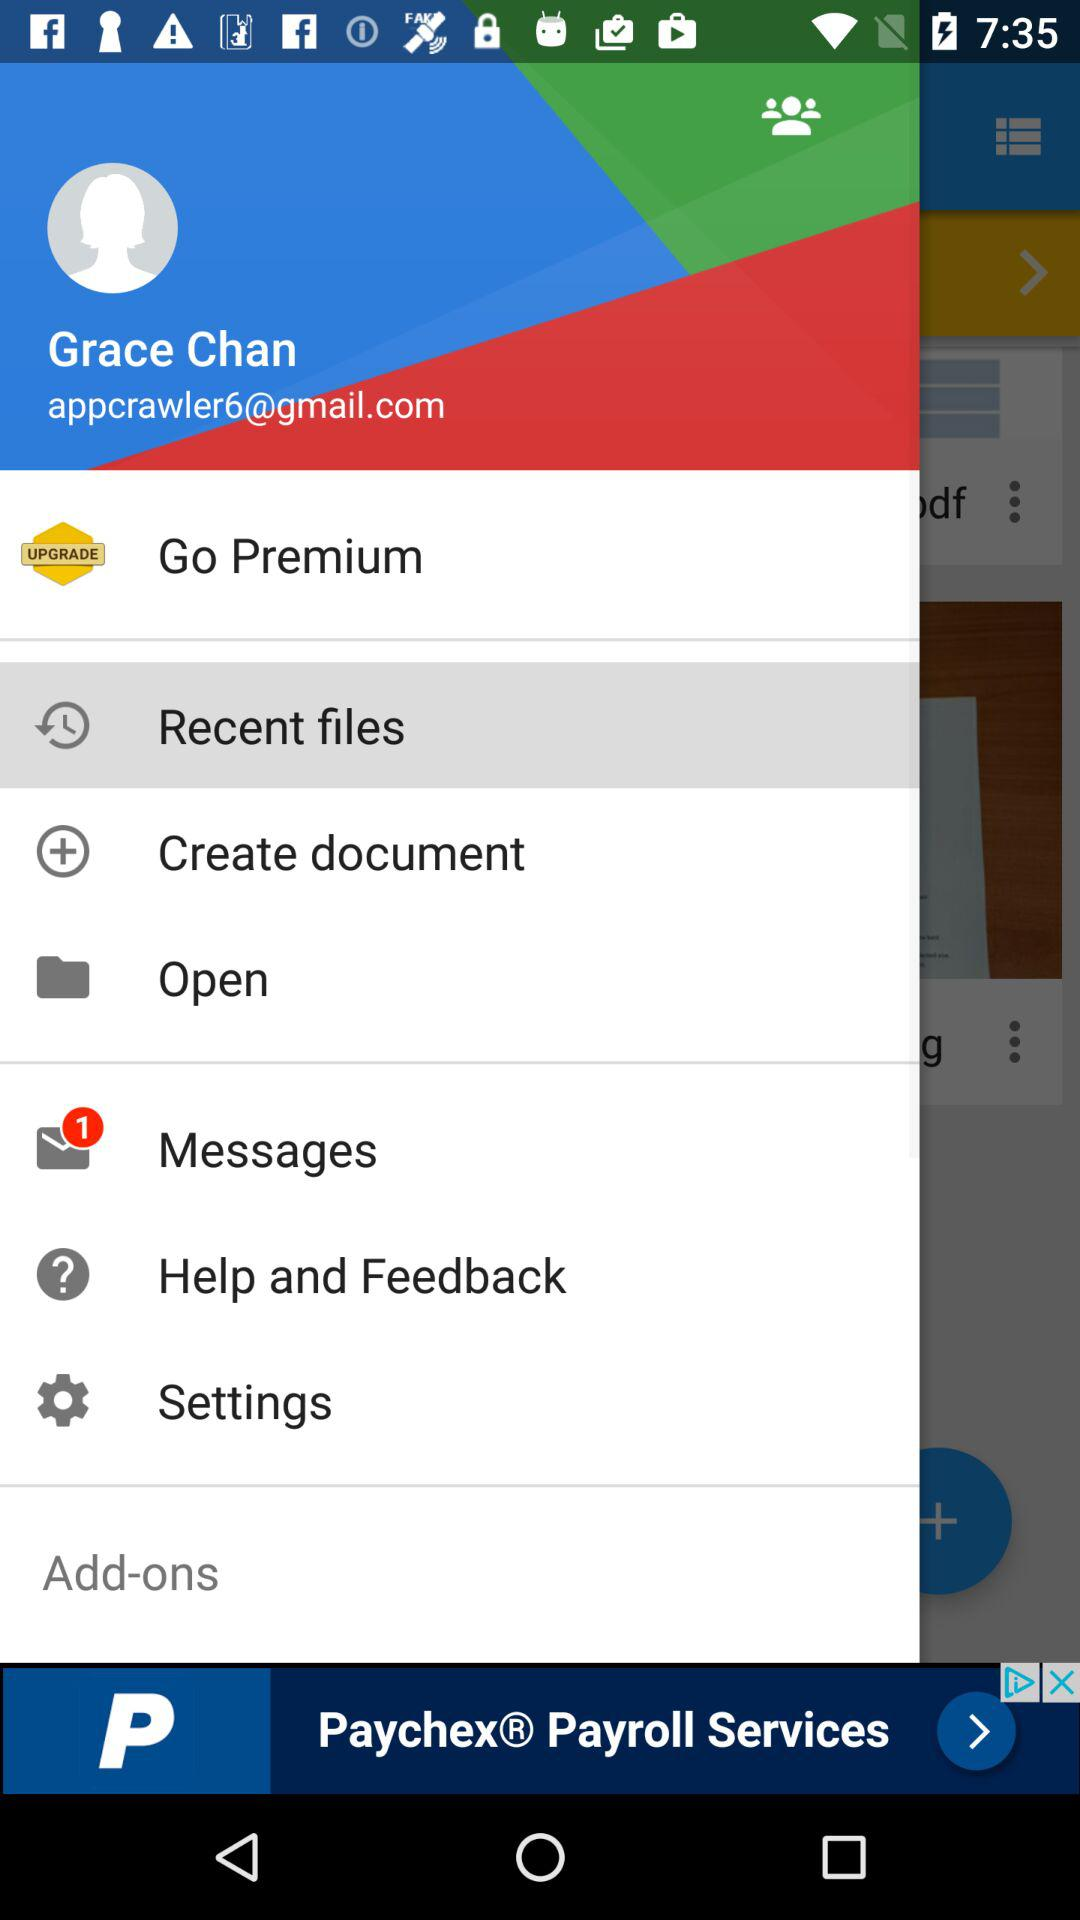How many unread messages are there? There is only 1 unread message. 